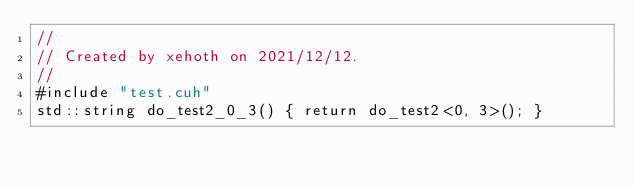<code> <loc_0><loc_0><loc_500><loc_500><_Cuda_>//
// Created by xehoth on 2021/12/12.
//
#include "test.cuh"
std::string do_test2_0_3() { return do_test2<0, 3>(); }
</code> 